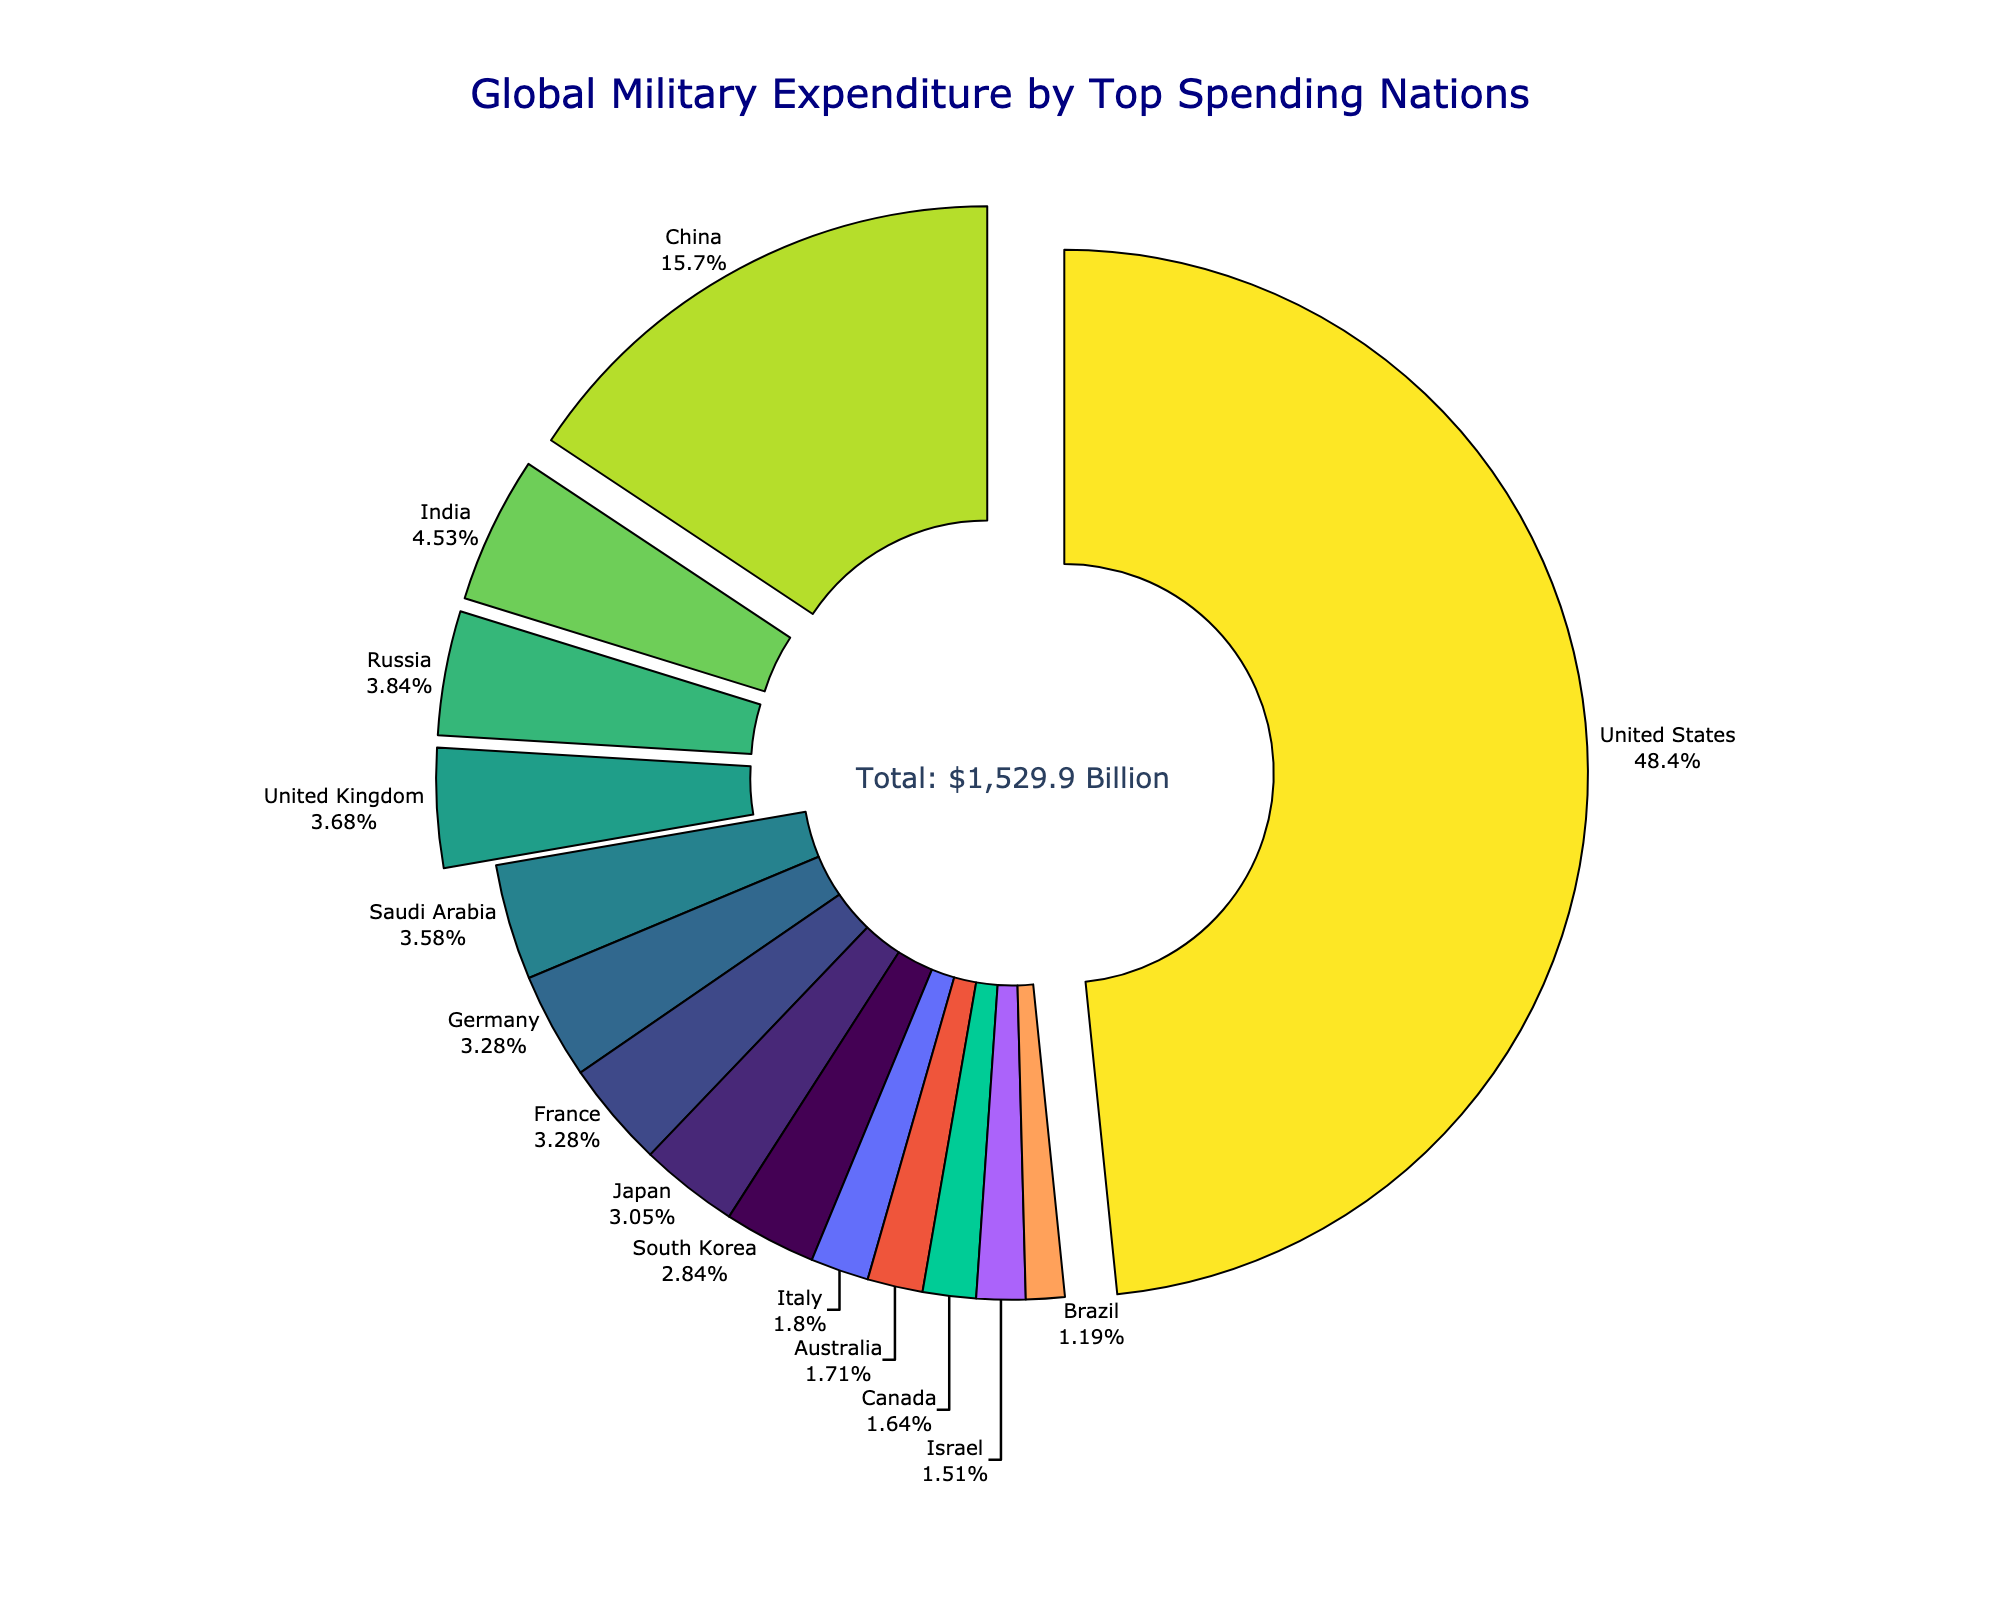what percentage of the total military expenditure is attributed to the top three spending nations? Identify the countries with the highest expenditures (United States, China, and India), and add their expenditures: 778 + 252 + 72.9 = 1102.9. The total expenditure is $1,529.9 billion. Calculate the percentage: (1102.9 / 1529.9) * 100 ≈ 72.1%
Answer: 72.1% Which country ranks fourth in military expenditure? From the sorted data on the pie chart, the country with the fourth highest expenditure is Russia
Answer: Russia What is the difference in military spending between the United States and China? Identify the expenditures for the United States (778 billion USD) and China (252 billion USD). Subtract China's spending from the United States': 778 - 252 = 526 billion USD
Answer: 526 billion USD Between Japan and the United Kingdom, which country spends less on military and by how much? Identify the expenditures of Japan (49.1 billion USD) and the United Kingdom (59.2 billion USD). Subtract Japan's spending from the United Kingdom's: 59.2 - 49.1 = 10.1 billion USD. Since Japan has a lower expenditure, the answer is Japan and 10.1 billion USD
Answer: Japan, 10.1 billion USD What is the combined military expenditure of France and Germany? Add the expenditures of France (52.7 billion USD) and Germany (52.8 billion USD): 52.7 + 52.8 = 105.5 billion USD
Answer: 105.5 billion USD How many countries have a military expenditure less than 30 billion USD? From the sorted data on the pie chart, the countries with expenditures less than 30 billion USD are Italy, Australia, Canada, Israel, and Brazil, making a total of 5 countries
Answer: 5 Which country has the smallest military expenditure and what is the amount? From the sorted data on the pie chart, Brazil has the smallest military expenditure at 19.2 billion USD
Answer: Brazil, 19.2 billion USD Which country contributes the largest portion of the global military expenditure pie chart and what is their percentage? From the pie chart, the United States contributes the largest portion. Its expenditure is 778 billion USD, and we calculated the total to be 1529.9 billion USD. (778 / 1529.9) * 100 ≈ 50.8%
Answer: United States, 50.8% 